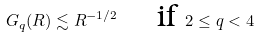Convert formula to latex. <formula><loc_0><loc_0><loc_500><loc_500>G _ { q } ( R ) \lesssim R ^ { - 1 / 2 } \quad \text { if } 2 \leq q < 4</formula> 